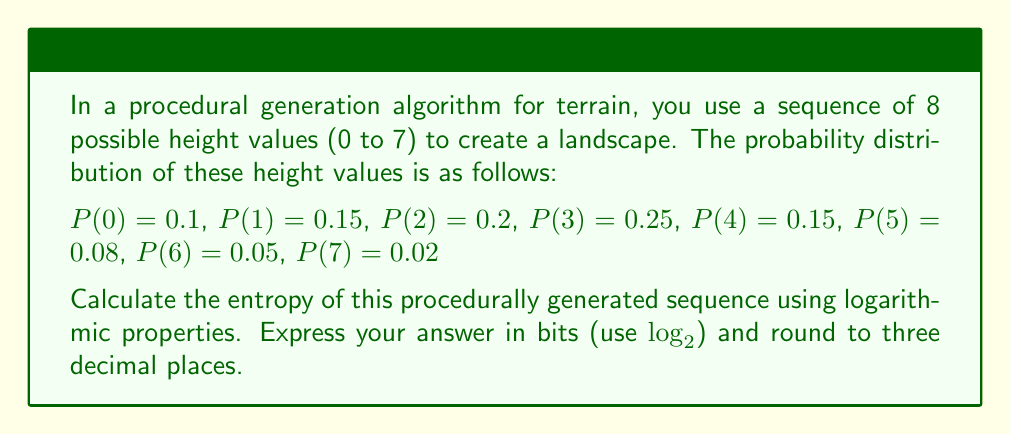Provide a solution to this math problem. To calculate the entropy of a discrete probability distribution, we use the formula:

$$H = -\sum_{i} P(i) \log_2 P(i)$$

where $P(i)$ is the probability of each outcome.

Let's calculate each term:

1) $-P(0) \log_2 P(0) = -0.1 \log_2 0.1 = 0.332$
2) $-P(1) \log_2 P(1) = -0.15 \log_2 0.15 = 0.411$
3) $-P(2) \log_2 P(2) = -0.2 \log_2 0.2 = 0.464$
4) $-P(3) \log_2 P(3) = -0.25 \log_2 0.25 = 0.5$
5) $-P(4) \log_2 P(4) = -0.15 \log_2 0.15 = 0.411$
6) $-P(5) \log_2 P(5) = -0.08 \log_2 0.08 = 0.292$
7) $-P(6) \log_2 P(6) = -0.05 \log_2 0.05 = 0.216$
8) $-P(7) \log_2 P(7) = -0.02 \log_2 0.02 = 0.113$

Now, we sum all these terms:

$$H = 0.332 + 0.411 + 0.464 + 0.5 + 0.411 + 0.292 + 0.216 + 0.113 = 2.739$$

Rounding to three decimal places, we get 2.739 bits.
Answer: 2.739 bits 